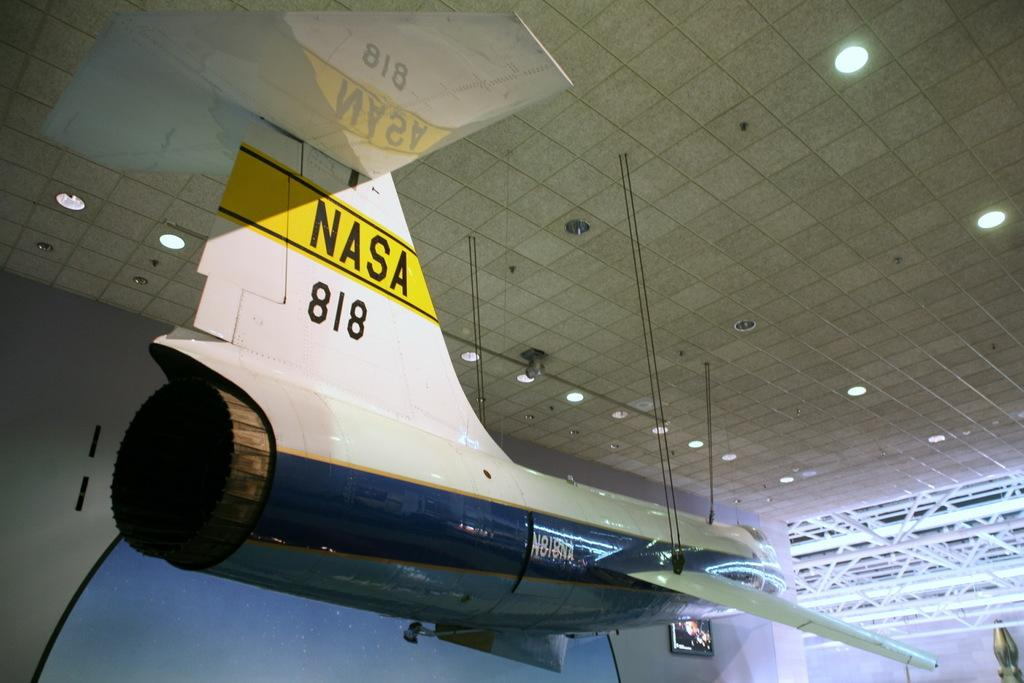<image>
Share a concise interpretation of the image provided. a NASA 818 shuttle is hanging from the ceiling 